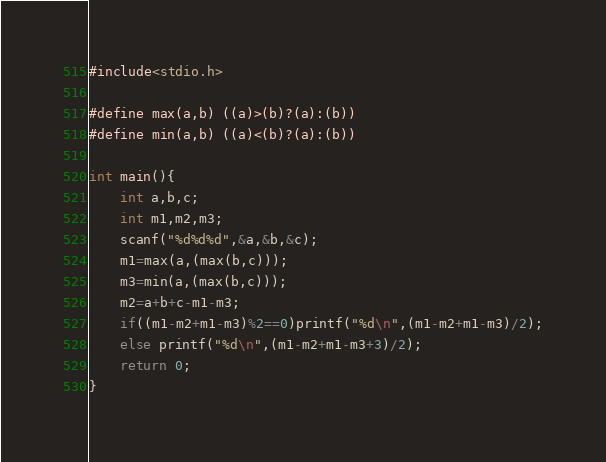<code> <loc_0><loc_0><loc_500><loc_500><_C_>#include<stdio.h>

#define max(a,b) ((a)>(b)?(a):(b))
#define min(a,b) ((a)<(b)?(a):(b))

int main(){
	int a,b,c;
	int m1,m2,m3;
	scanf("%d%d%d",&a,&b,&c);
	m1=max(a,(max(b,c)));
	m3=min(a,(max(b,c)));
	m2=a+b+c-m1-m3;
	if((m1-m2+m1-m3)%2==0)printf("%d\n",(m1-m2+m1-m3)/2);
	else printf("%d\n",(m1-m2+m1-m3+3)/2);
	return 0;
}</code> 